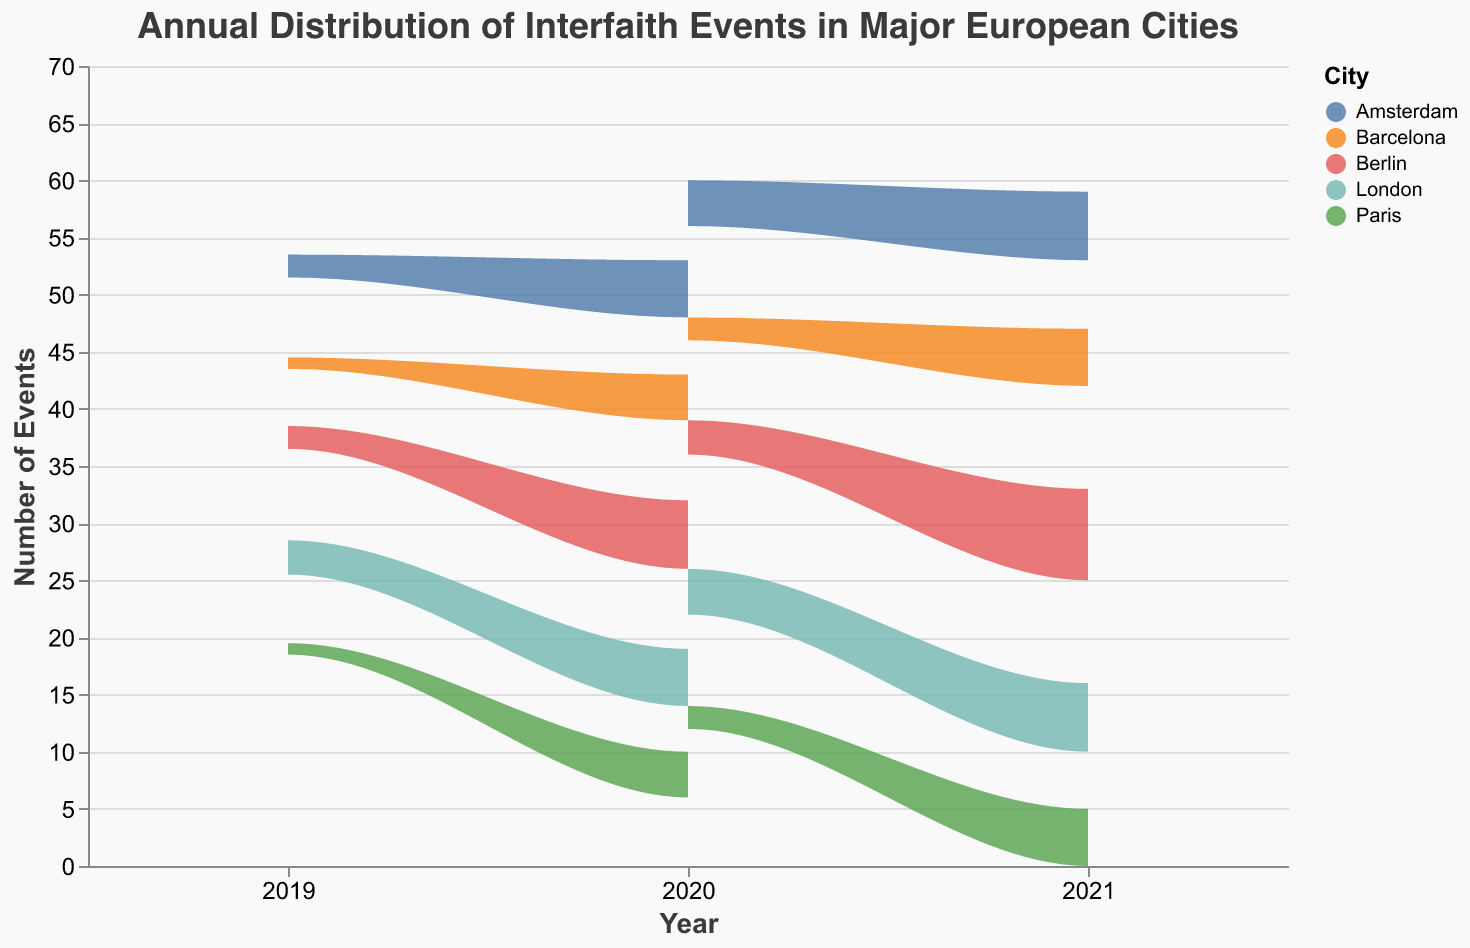What is the title of the figure? The title is located at the top of the figure, typically in a larger font size compared to other text elements.
Answer: Annual Distribution of Interfaith Events in Major European Cities How many cities are represented in the figure? The cities are indicated by different color areas within the stream graph, and the legend on the right side lists all the cities.
Answer: 5 What is the general trend of interfaith events in Berlin from 2019 to 2021? By observing the height change of the Berlin area's section over the years on the x-axis, we can see how it grows.
Answer: Increasing Which year saw the highest number of interfaith events in Amsterdam? Observing the peak in the Amsterdam section of the stream graph reveals the year with the highest value.
Answer: 2021 Comparing London and Paris, which city had more interfaith events in 2020? By comparing the height of the areas representing London and Paris in 2020, we can determine which had more events.
Answer: London What event type is not visualized separately in the graph? The graph combines all events together for each city, so individual event types such as Interfaith Dialogue Conference, Community Service Collaboration, and Youth Interfaith Workshop are not separately visualized.
Answer: Event types are combined Which city had the greatest increase in interfaith events from 2020 to 2021? By comparing the growth in area heights between 2020 and 2021 for each city, the city with the largest increase can be identified.
Answer: Berlin How many more interfaith events were there in Berlin in 2021 compared to 2019? Compare the height of Berlin’s section in 2019 and 2021, then calculate the difference in total counts. Berlin had 15 events in 2019 (5 + 3 + 2) and 17 in 2021 (8 + 5 + 4).
Answer: 2 more Which city had the least number of interfaith events in 2019? By examining the height of the different areas in the year 2019, we can identify the city with the smallest area.
Answer: Paris What is the total number of interfaith events in Barcelona over the period 2019-2021? Summing up the counts of events for each year for Barcelona gives us the total: (3 + 2 + 1) + (4 + 3 + 2) + (5 + 3 + 3) = 26.
Answer: 26 